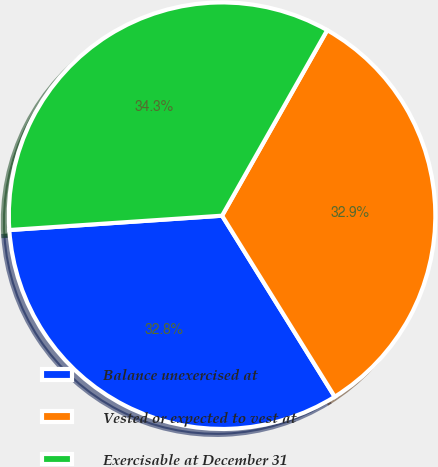<chart> <loc_0><loc_0><loc_500><loc_500><pie_chart><fcel>Balance unexercised at<fcel>Vested or expected to vest at<fcel>Exercisable at December 31<nl><fcel>32.79%<fcel>32.94%<fcel>34.28%<nl></chart> 